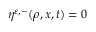<formula> <loc_0><loc_0><loc_500><loc_500>\eta ^ { { \varepsilon } , - } ( \rho , x , t ) = 0</formula> 